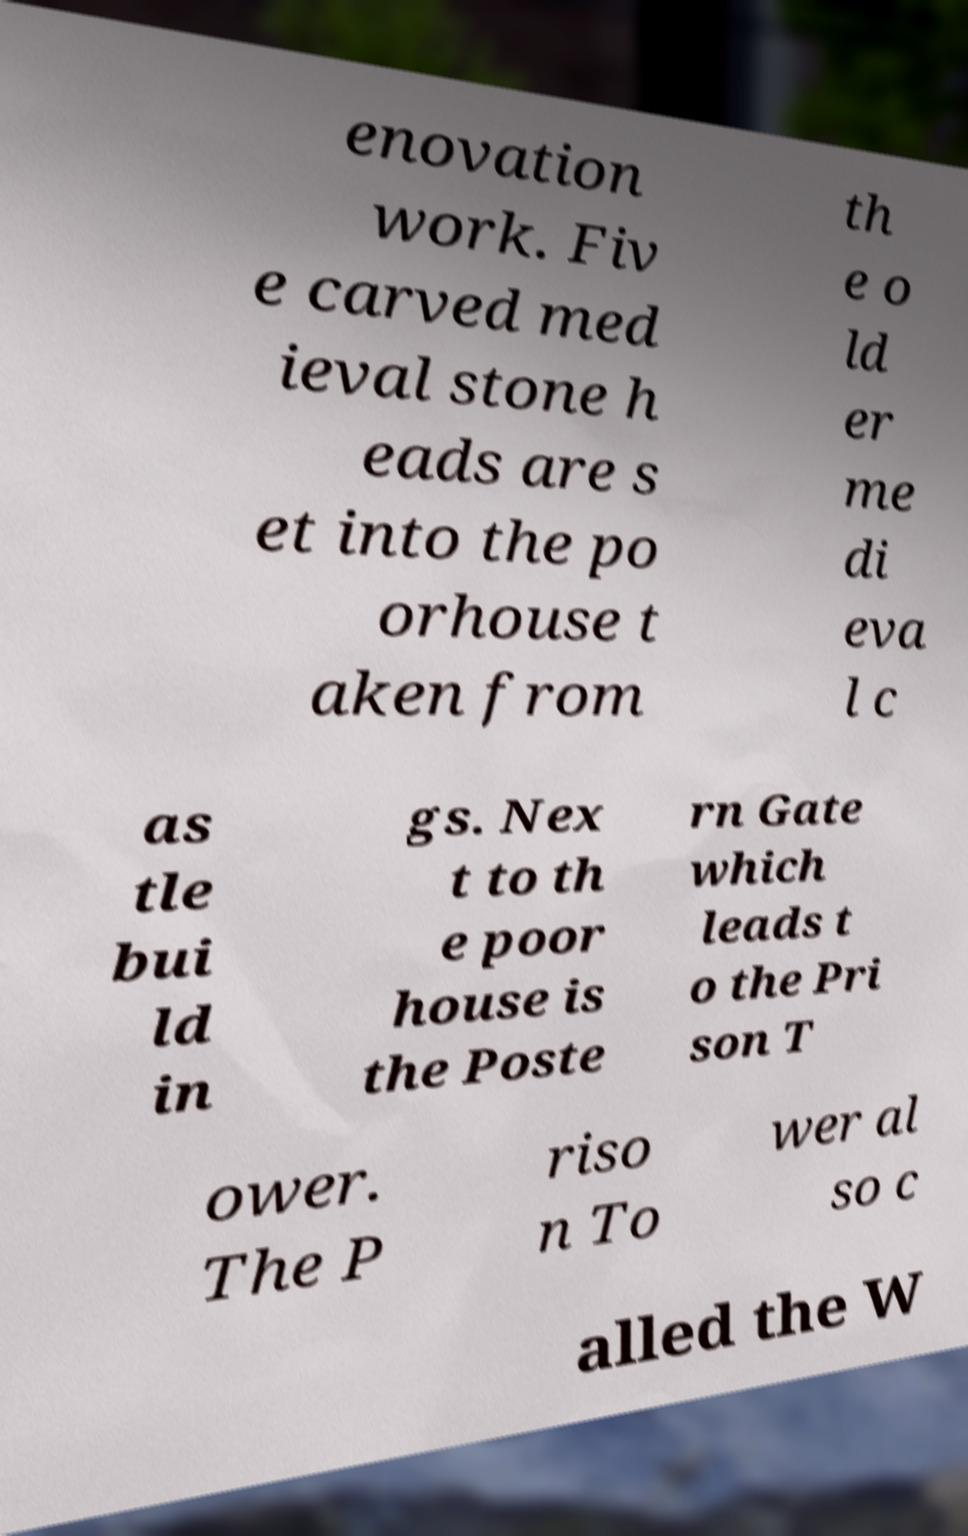Could you extract and type out the text from this image? enovation work. Fiv e carved med ieval stone h eads are s et into the po orhouse t aken from th e o ld er me di eva l c as tle bui ld in gs. Nex t to th e poor house is the Poste rn Gate which leads t o the Pri son T ower. The P riso n To wer al so c alled the W 